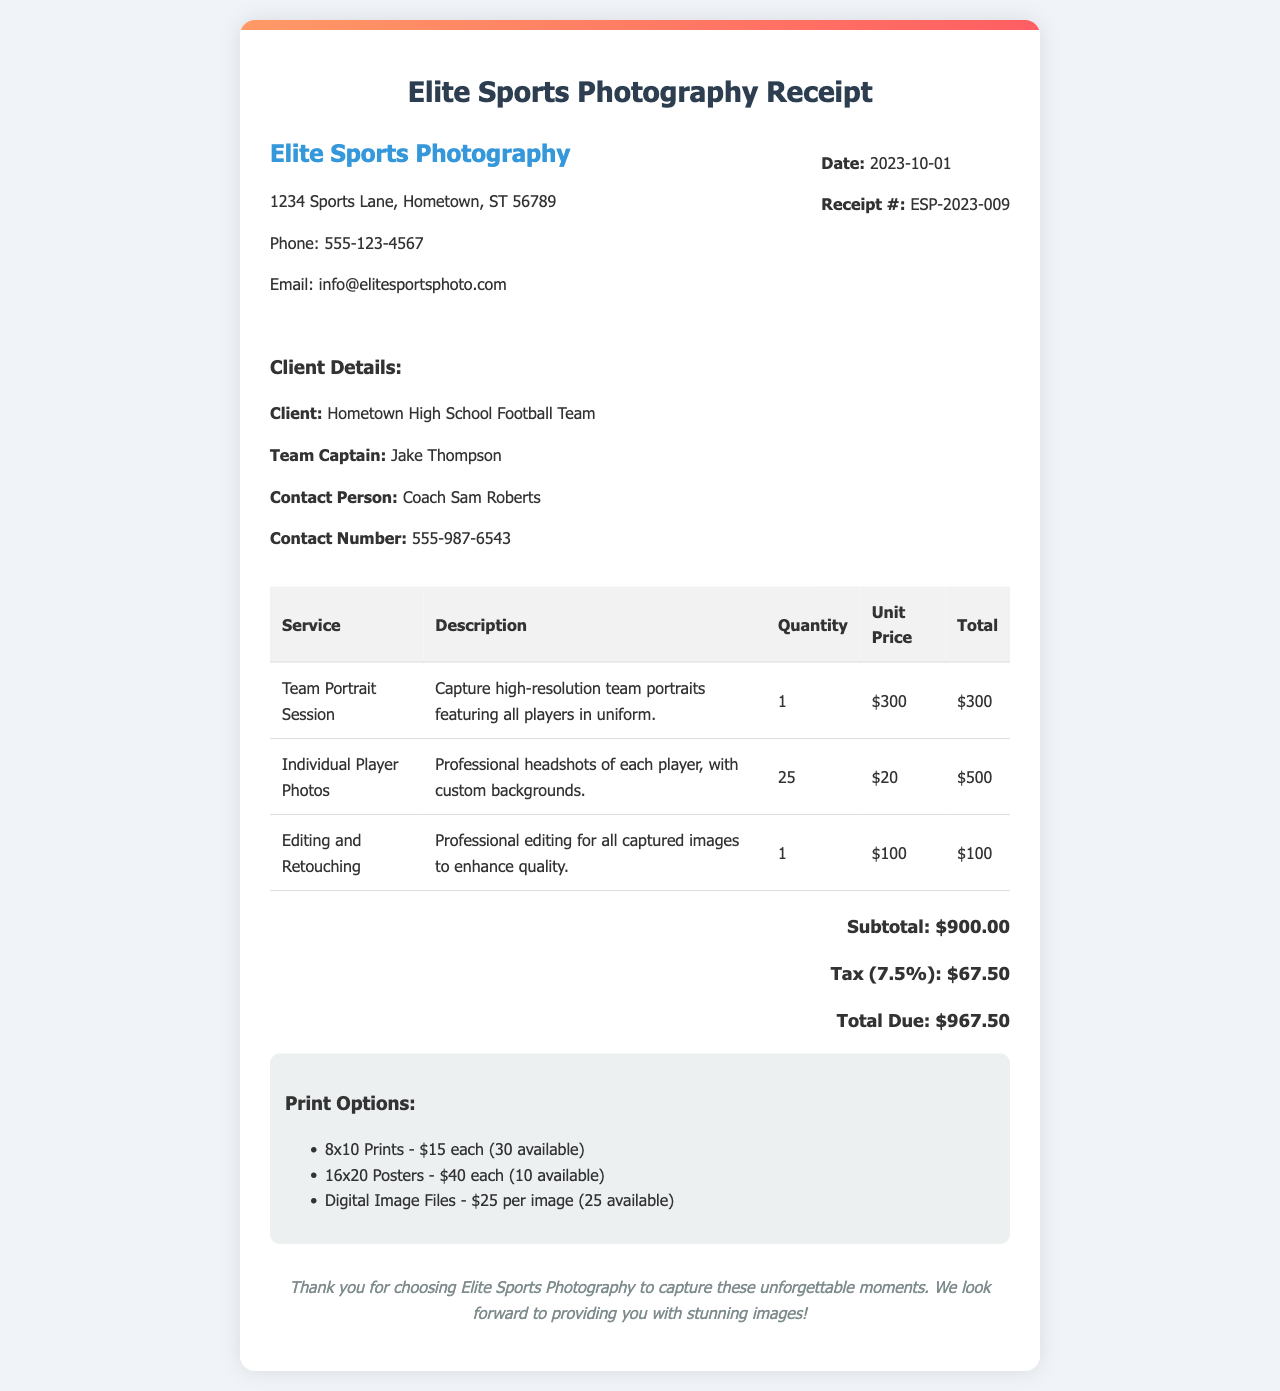What is the date of the receipt? The date of the receipt is stated in the document as October 1, 2023.
Answer: 2023-10-01 What is the total due amount? The total due amount is the final amount listed at the bottom of the receipt, including tax.
Answer: $967.50 Who is the Team Captain? The document mentions the Team Captain's name under client details.
Answer: Jake Thompson How many individual player photos were ordered? The quantity of individual player photos is indicated in the service breakdown section of the receipt.
Answer: 25 What is the service charge for the Team Portrait Session? The unit price for the Team Portrait Session is given in the receipt.
Answer: $300 What is the tax rate applied to the total? The tax rate can be calculated based on the tax amount provided in the receipt.
Answer: 7.5% Which service includes professional editing for images? The document specifies the service related to editing in the breakdown table.
Answer: Editing and Retouching What are the available sizes for prints listed? The print options section details the sizes available for prints in the document.
Answer: 8x10 Prints, 16x20 Posters What is the contact number for the contact person? The contact number for Coach Sam Roberts is displayed in the client details section.
Answer: 555-987-6543 